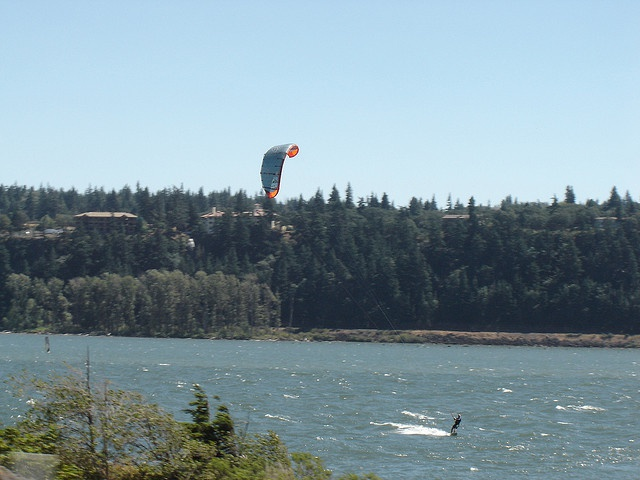Describe the objects in this image and their specific colors. I can see kite in lightblue, blue, darkgray, and gray tones, people in lightblue, black, gray, and darkgray tones, and people in lightblue and gray tones in this image. 